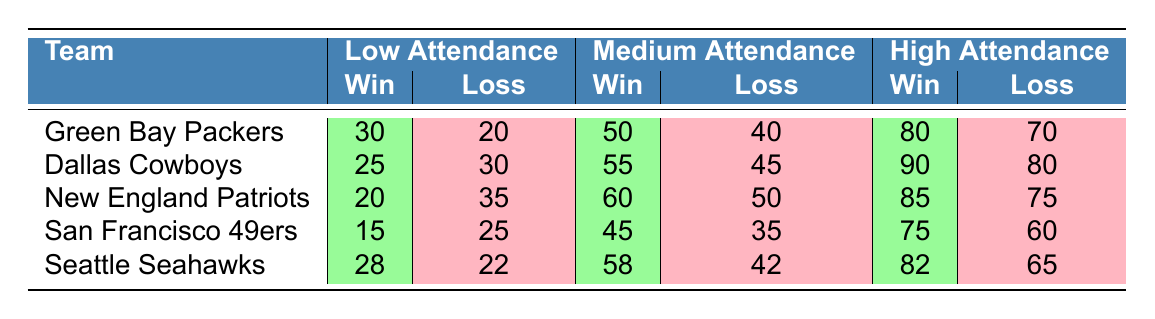What is the win count for the Green Bay Packers with low attendance? From the table, we can directly see that for the Green Bay Packers, under low attendance, the win count is 30.
Answer: 30 Which team has the highest win total with medium attendance? Looking at the medium attendance column, the win counts are as follows: Green Bay Packers (50), Dallas Cowboys (55), New England Patriots (60), San Francisco 49ers (45), and Seattle Seahawks (58). The New England Patriots have the highest win total with 60 wins.
Answer: New England Patriots Is the loss count for the Dallas Cowboys higher than that of the San Francisco 49ers under high attendance? The loss counts are Dallas Cowboys (80) and San Francisco 49ers (60) under high attendance. Since 80 is greater than 60, the statement is true.
Answer: Yes What is the average win count for all teams under low attendance? To find the average for wins under low attendance, we sum the values: 30 (Packers) + 25 (Cowboys) + 20 (Patriots) + 15 (49ers) + 28 (Seahawks) = 118. There are 5 teams, so the average is 118 / 5 = 23.6.
Answer: 23.6 Is there a team that has the same win count under low and medium attendance? Checking the win counts: Green Bay Packers (30, 50), Dallas Cowboys (25, 55), New England Patriots (20, 60), San Francisco 49ers (15, 45), and Seattle Seahawks (28, 58). None have the same win count in both categories, so the statement is false.
Answer: No 